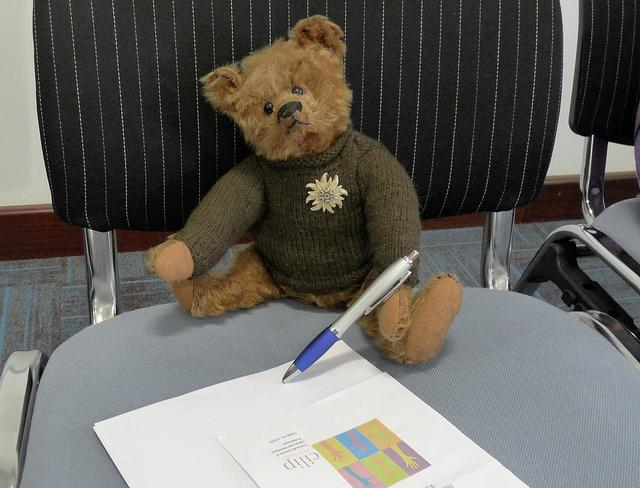What is the pen used to do on the paper?

Choices:
A) stab
B) write
C) poke
D) massage write 